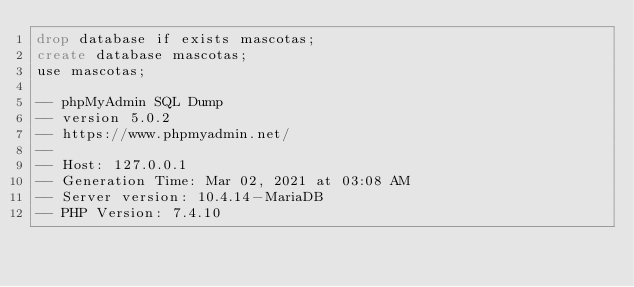Convert code to text. <code><loc_0><loc_0><loc_500><loc_500><_SQL_>drop database if exists mascotas;
create database mascotas;
use mascotas;

-- phpMyAdmin SQL Dump
-- version 5.0.2
-- https://www.phpmyadmin.net/
--
-- Host: 127.0.0.1
-- Generation Time: Mar 02, 2021 at 03:08 AM
-- Server version: 10.4.14-MariaDB
-- PHP Version: 7.4.10
</code> 